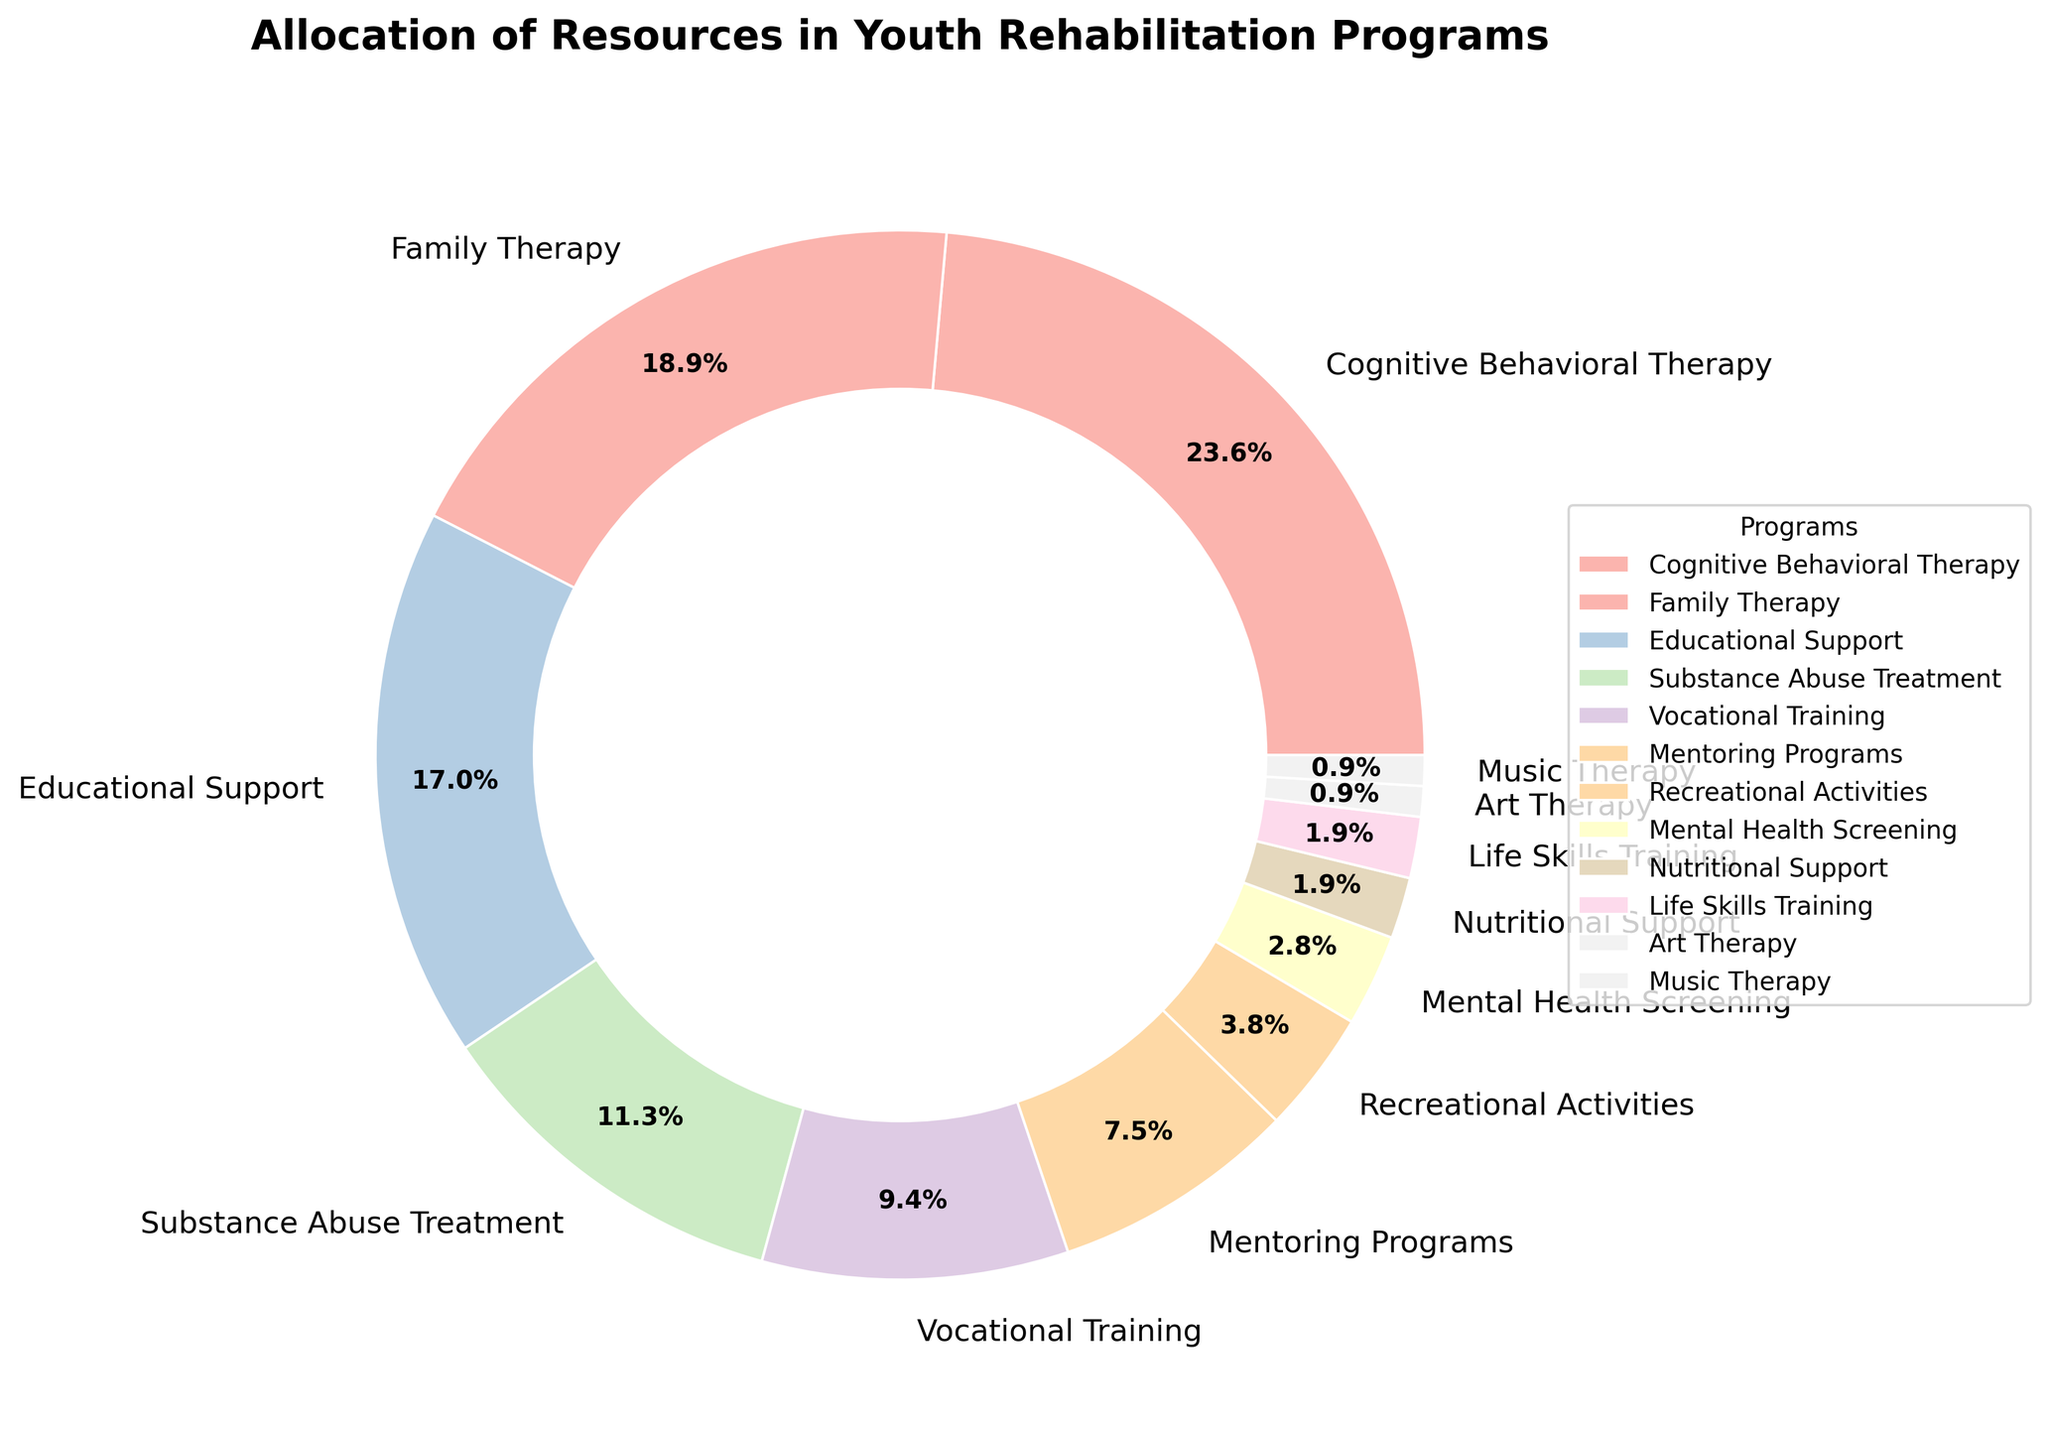What is the most funded youth rehabilitation program in terms of resource allocation? By examining the pie chart, Cognitive Behavioral Therapy accounts for the largest section.
Answer: Cognitive Behavioral Therapy Which two programs have the smallest allocation percentage and what is their combined percentage? The two smallest sections on the pie chart are Art Therapy and Music Therapy, each contributing 1%. Combined, their total percentage is 2%.
Answer: Art Therapy and Music Therapy, 2% How much greater is the resource allocation for Cognitive Behavioral Therapy compared to Vocational Training? Cognitive Behavioral Therapy has 25%, while Vocational Training has 10%. The difference is found by subtracting 10 from 25.
Answer: 15% What is the total percentage allocation for Educational Support, Family Therapy, and Substance Abuse Treatment combined? Adding the percentages for Educational Support (18%), Family Therapy (20%), and Substance Abuse Treatment (12%) gives the total allocation.
Answer: 50% Which program receives more resources: Mentoring Programs or Recreational Activities, and by how much? Mentoring Programs are given 8%, whereas Recreational Activities have 4%. The difference is 8 - 4.
Answer: Mentoring Programs, 4% What color is used to represent Nutritional Support in the pie chart? From the visual colors, Nutritional Support is represented by a light pastel shade.
Answer: Light pastel shade What is the combined percentage for all programs receiving less than 5% of the resource allocation each? Adding the percentages for Mental Health Screening (3%), Nutritional Support (2%), Life Skills Training (2%), Art Therapy (1%), and Music Therapy (1%) yields the total.
Answer: 9% Which type of rehabilitative program receives slightly more resources: Vocational Training or Substance Abuse Treatment? Vocational Training is allocated 10%, whereas Substance Abuse Treatment is allocated 12%. Thus, Substance Abuse Treatment receives slightly more resources.
Answer: Substance Abuse Treatment If the funding for Family Therapy doubled, what would its new percentage allocation be, assuming the total percentage remains 100%? Family Therapy is currently at 20%. Doubling this percentage makes it 40%. Hence, the overall allocation would need to adjust accordingly while keeping the total as 100%.
Answer: 40% Are there any programs with equal resource allocations? If so, which ones? Both Nutritional Support and Life Skills Training each have an allocation of 2%, indicating they are equal.
Answer: Nutritional Support and Life Skills Training 